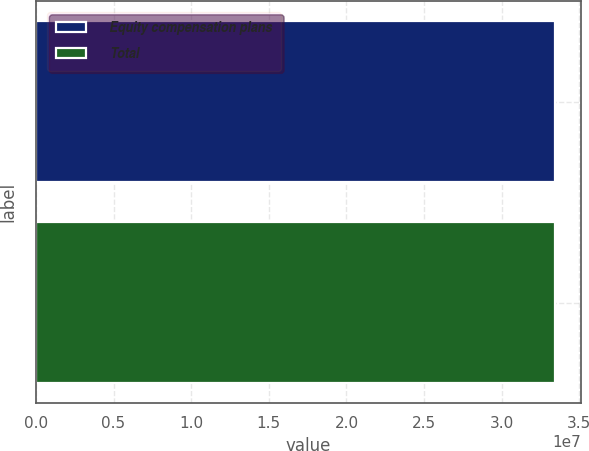<chart> <loc_0><loc_0><loc_500><loc_500><bar_chart><fcel>Equity compensation plans<fcel>Total<nl><fcel>3.34424e+07<fcel>3.34424e+07<nl></chart> 